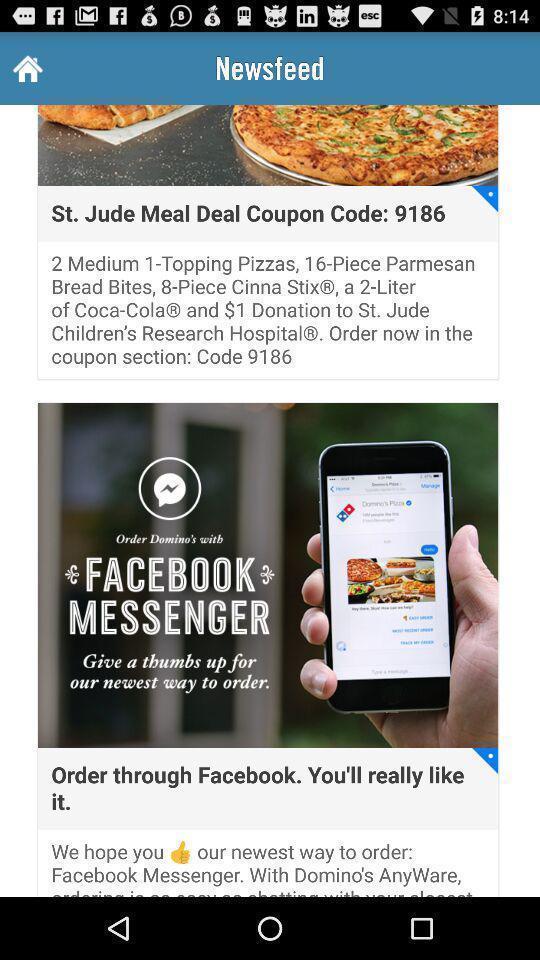Provide a textual representation of this image. Screen displaying the news feed page. 